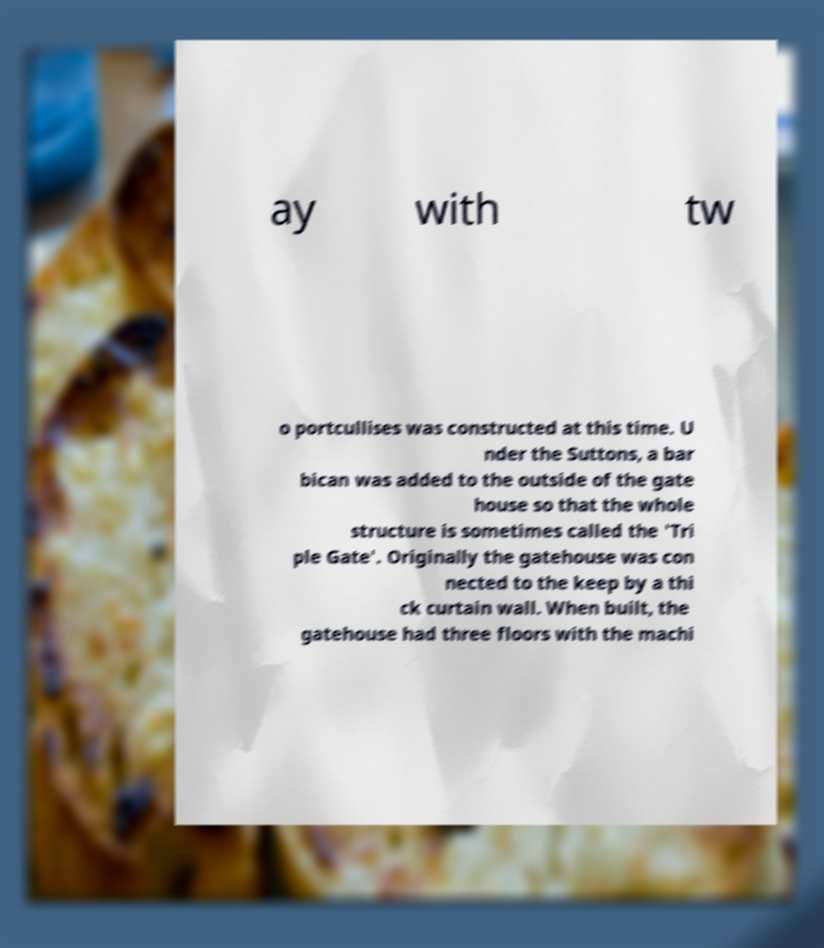For documentation purposes, I need the text within this image transcribed. Could you provide that? ay with tw o portcullises was constructed at this time. U nder the Suttons, a bar bican was added to the outside of the gate house so that the whole structure is sometimes called the 'Tri ple Gate'. Originally the gatehouse was con nected to the keep by a thi ck curtain wall. When built, the gatehouse had three floors with the machi 